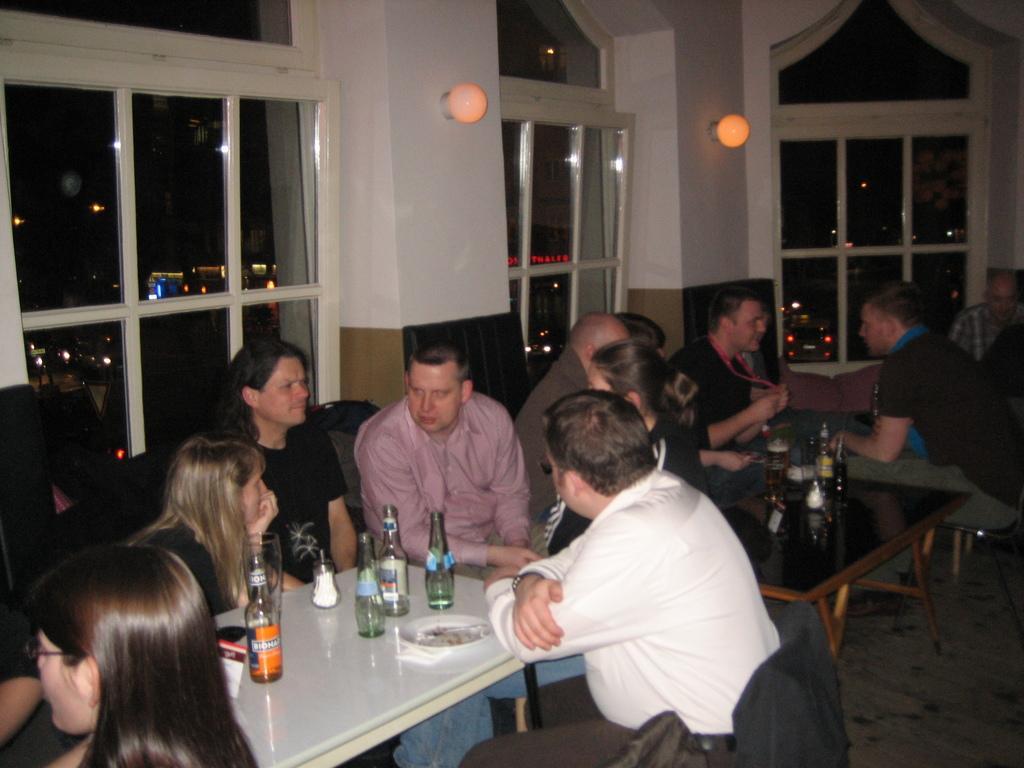In one or two sentences, can you explain what this image depicts? In this picture of group of five people sitting here and talking, there is a table in front of them with some beverage and wine bottles kept on the table also there is another table beside them with some people sitting and discussing, in the backdrop this wall a lamp and window 